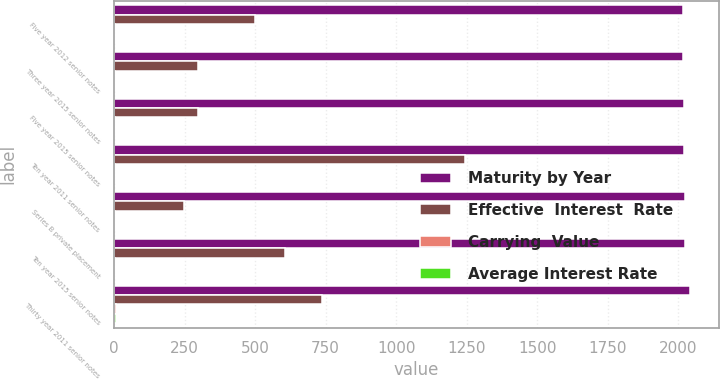Convert chart. <chart><loc_0><loc_0><loc_500><loc_500><stacked_bar_chart><ecel><fcel>Five year 2012 senior notes<fcel>Three year 2015 senior notes<fcel>Five year 2015 senior notes<fcel>Ten year 2011 senior notes<fcel>Series B private placement<fcel>Ten year 2015 senior notes<fcel>Thirty year 2011 senior notes<nl><fcel>Maturity by Year<fcel>2017<fcel>2018<fcel>2020<fcel>2021<fcel>2023<fcel>2025<fcel>2041<nl><fcel>Effective  Interest  Rate<fcel>498.9<fcel>298.9<fcel>298.6<fcel>1244.8<fcel>249.2<fcel>604.3<fcel>738.7<nl><fcel>Carrying  Value<fcel>1.45<fcel>1.55<fcel>2.25<fcel>4.35<fcel>4.32<fcel>2.63<fcel>5.5<nl><fcel>Average Interest Rate<fcel>1.45<fcel>1.55<fcel>2.25<fcel>4.35<fcel>4.32<fcel>2.63<fcel>5.5<nl></chart> 